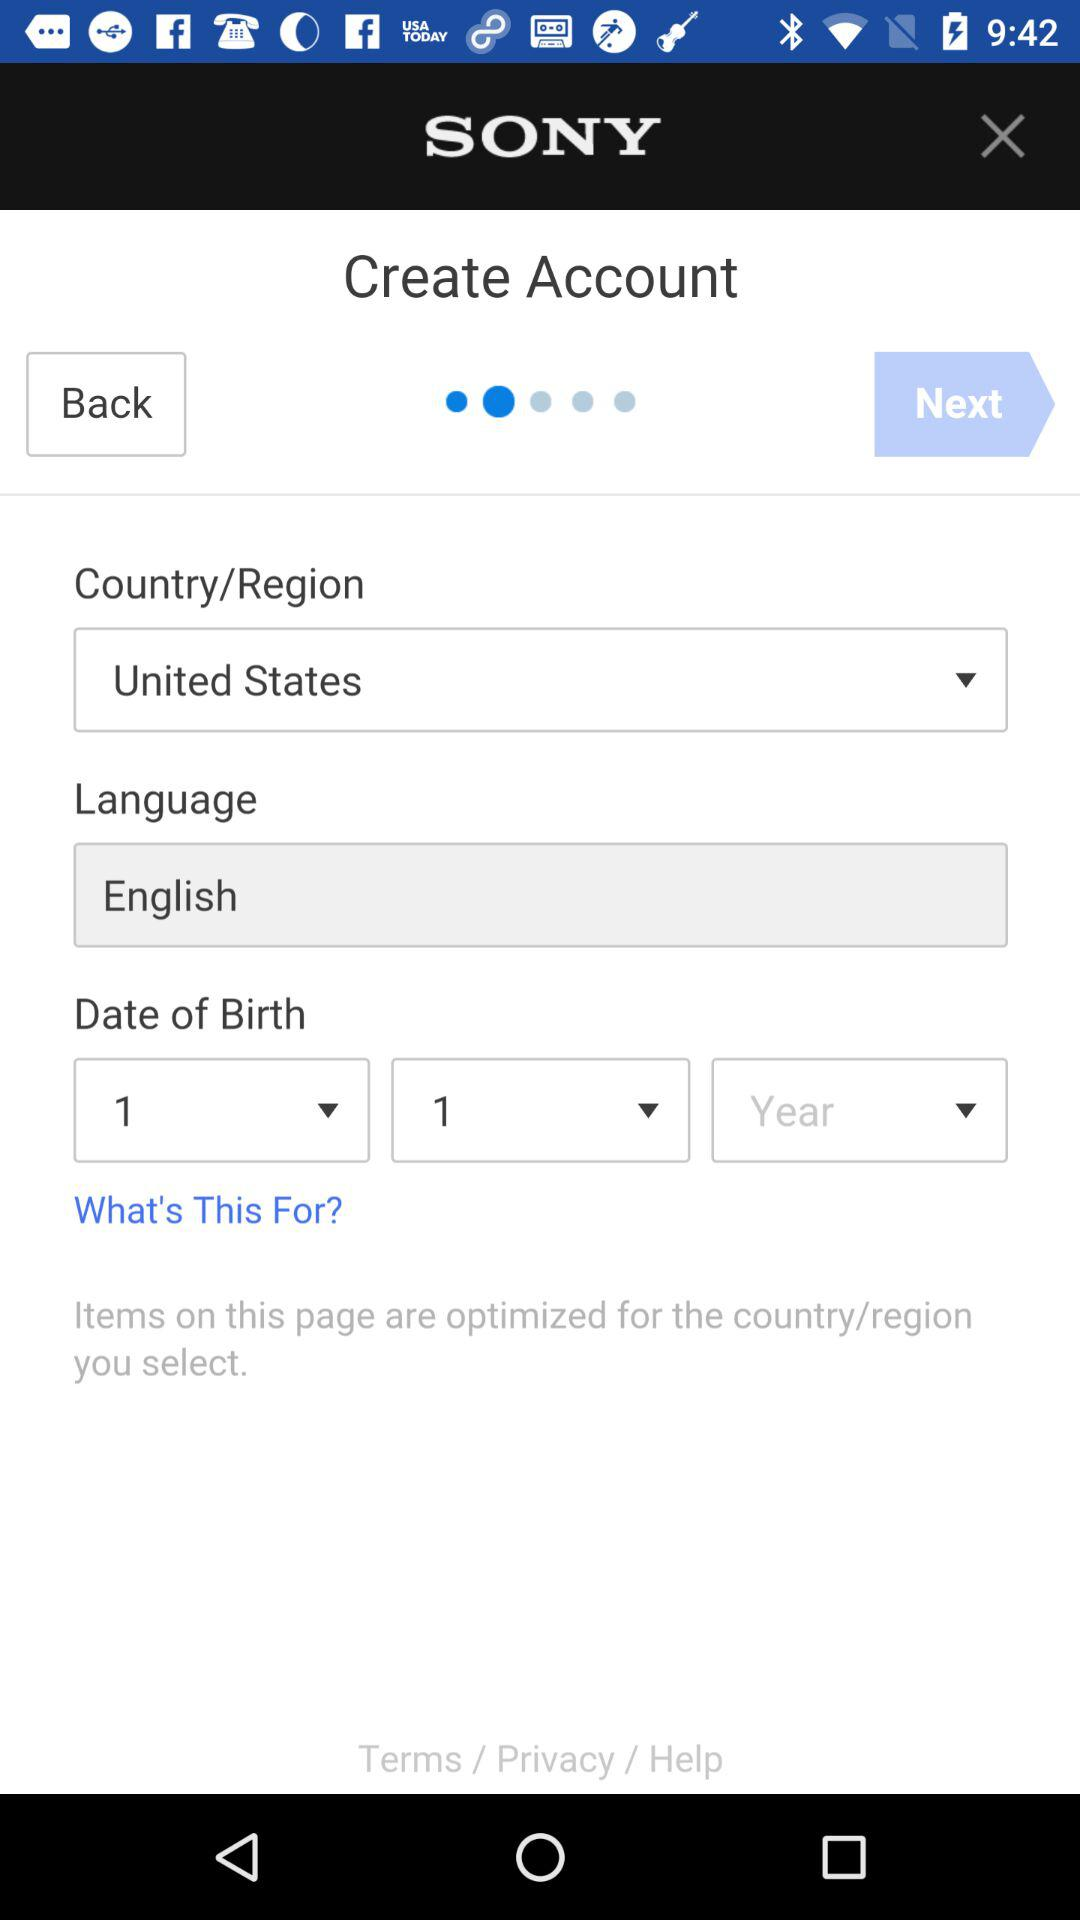What is the country name? The name of the country is the United States. 